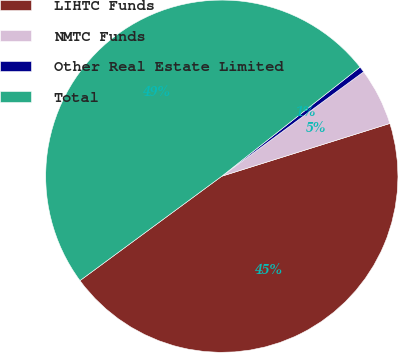<chart> <loc_0><loc_0><loc_500><loc_500><pie_chart><fcel>LIHTC Funds<fcel>NMTC Funds<fcel>Other Real Estate Limited<fcel>Total<nl><fcel>44.74%<fcel>5.26%<fcel>0.53%<fcel>49.47%<nl></chart> 